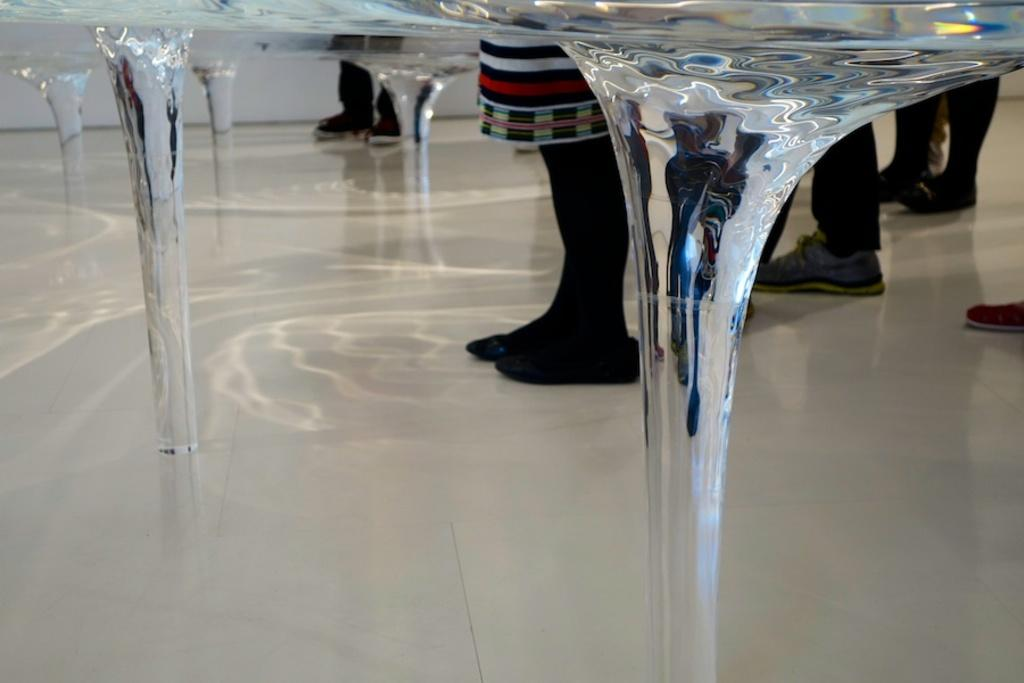What body parts are visible in the image? There are people's legs visible in the image. What type of furniture can be seen in the image? There is a table at the top of the image. How does the bridge start in the image? There is no bridge present in the image. What type of trail can be seen in the image? There is no trail present in the image. 